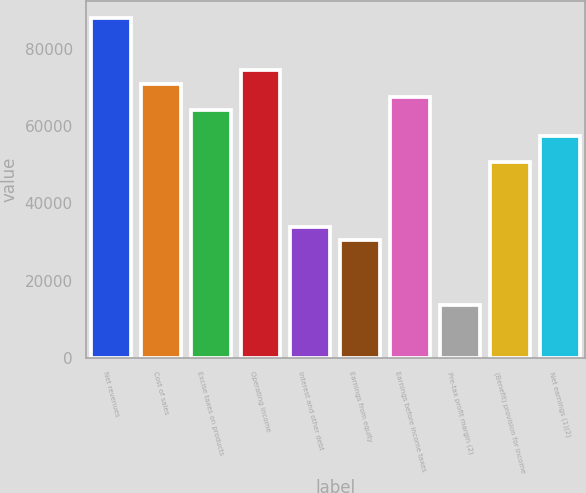Convert chart to OTSL. <chart><loc_0><loc_0><loc_500><loc_500><bar_chart><fcel>Net revenues<fcel>Cost of sales<fcel>Excise taxes on products<fcel>Operating income<fcel>Interest and other debt<fcel>Earnings from equity<fcel>Earnings before income taxes<fcel>Pre-tax profit margin (2)<fcel>(Benefit) provision for income<fcel>Net earnings (1)(2)<nl><fcel>88028<fcel>71099.9<fcel>64328.6<fcel>74485.5<fcel>33858<fcel>30472.4<fcel>67714.2<fcel>13544.3<fcel>50786.1<fcel>57557.4<nl></chart> 